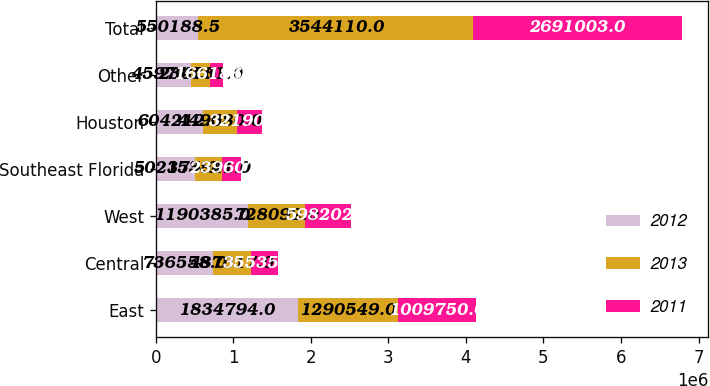Convert chart to OTSL. <chart><loc_0><loc_0><loc_500><loc_500><stacked_bar_chart><ecel><fcel>East<fcel>Central<fcel>West<fcel>Southeast Florida<fcel>Houston<fcel>Other<fcel>Total<nl><fcel>2012<fcel>1.83479e+06<fcel>736558<fcel>1.19038e+06<fcel>502175<fcel>604212<fcel>459743<fcel>550188<nl><fcel>2013<fcel>1.29055e+06<fcel>487317<fcel>728092<fcel>353841<fcel>449580<fcel>234731<fcel>3.54411e+06<nl><fcel>2011<fcel>1.00975e+06<fcel>355350<fcel>598202<fcel>239607<fcel>321908<fcel>166186<fcel>2.691e+06<nl></chart> 